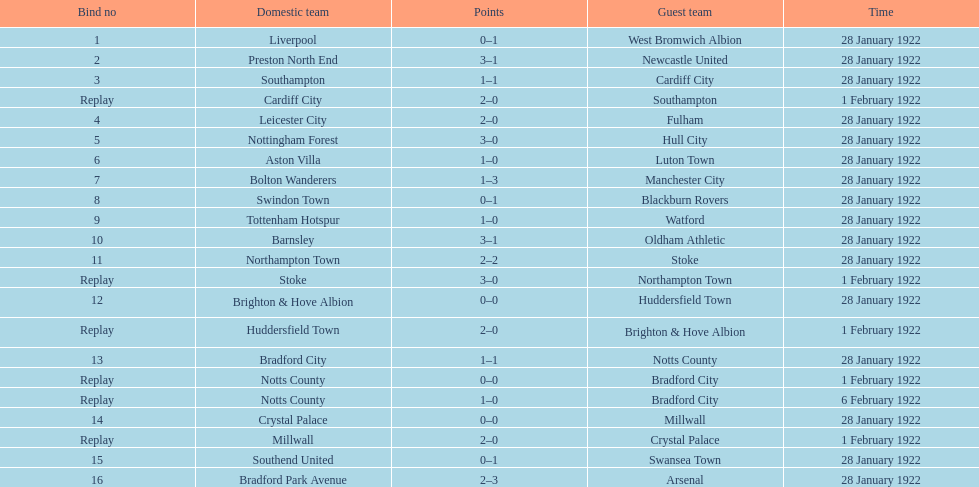How many total points were scored in the second round proper? 45. 